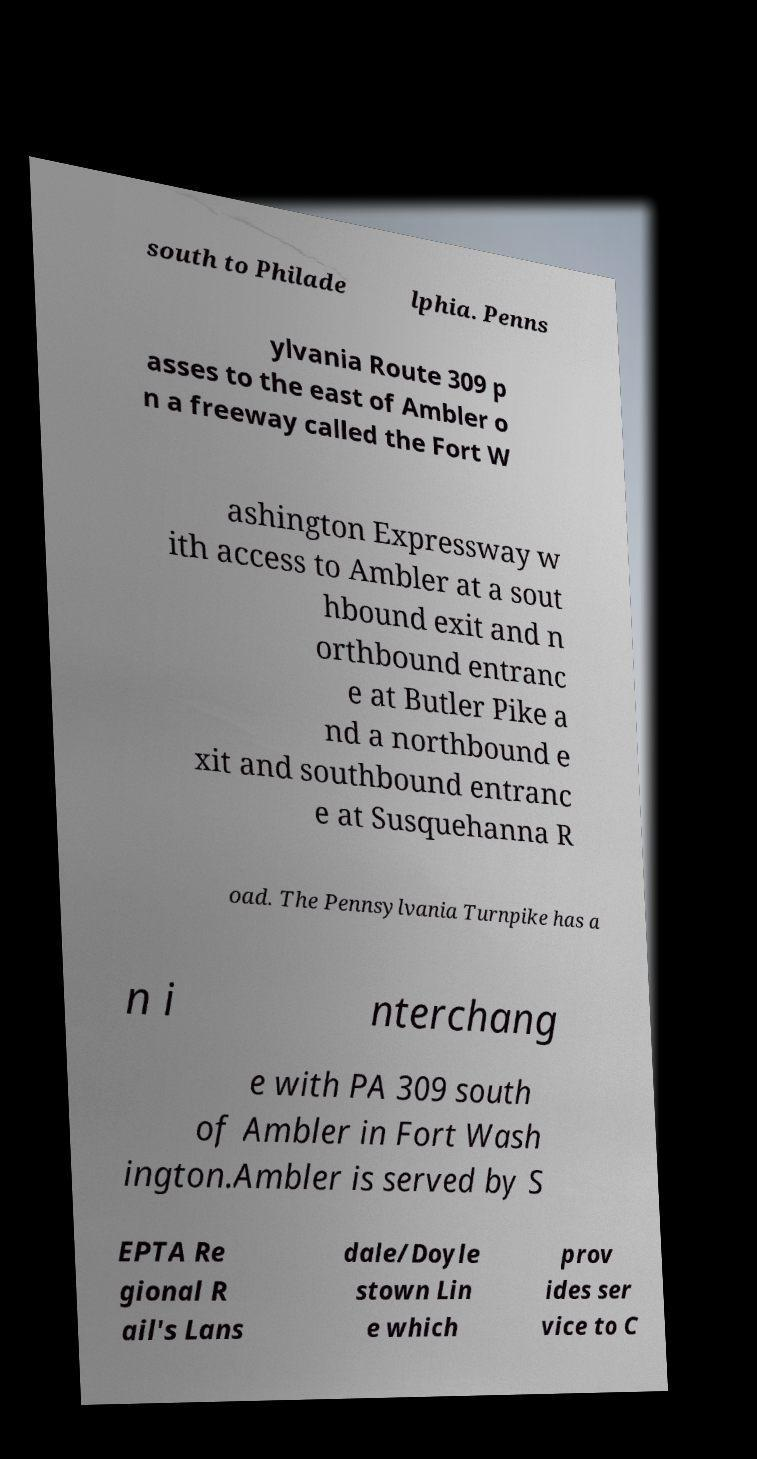Could you assist in decoding the text presented in this image and type it out clearly? south to Philade lphia. Penns ylvania Route 309 p asses to the east of Ambler o n a freeway called the Fort W ashington Expressway w ith access to Ambler at a sout hbound exit and n orthbound entranc e at Butler Pike a nd a northbound e xit and southbound entranc e at Susquehanna R oad. The Pennsylvania Turnpike has a n i nterchang e with PA 309 south of Ambler in Fort Wash ington.Ambler is served by S EPTA Re gional R ail's Lans dale/Doyle stown Lin e which prov ides ser vice to C 